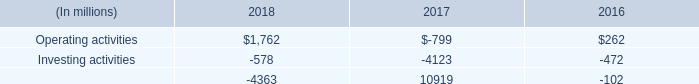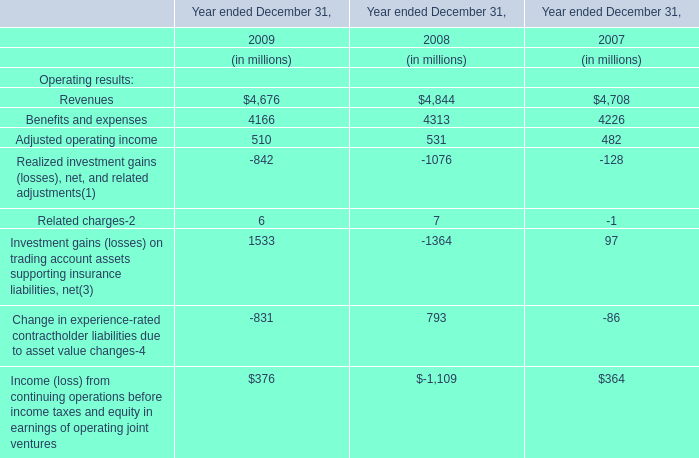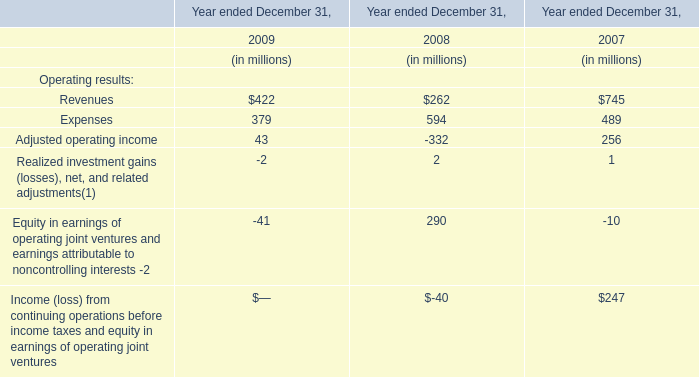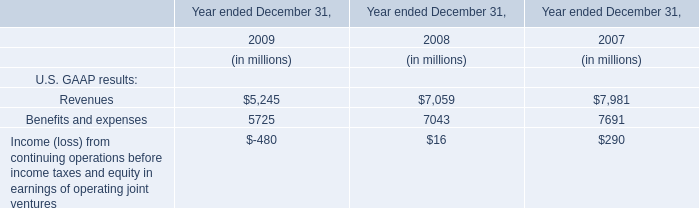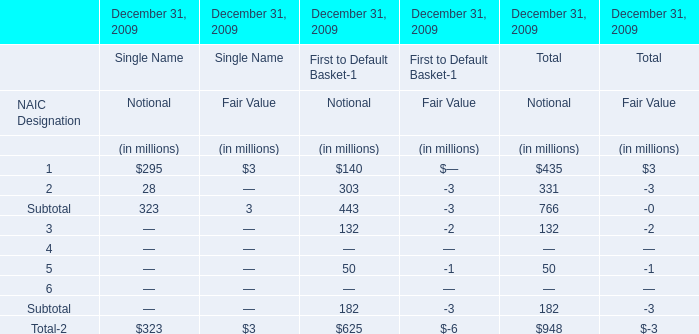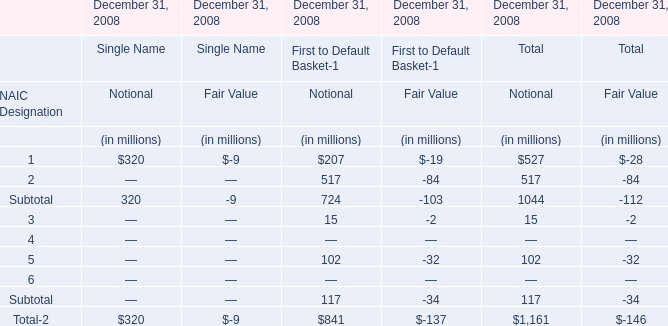what is the net change in cash during 2018? 
Computations: ((1762 + -578) + -4363)
Answer: -3179.0. 